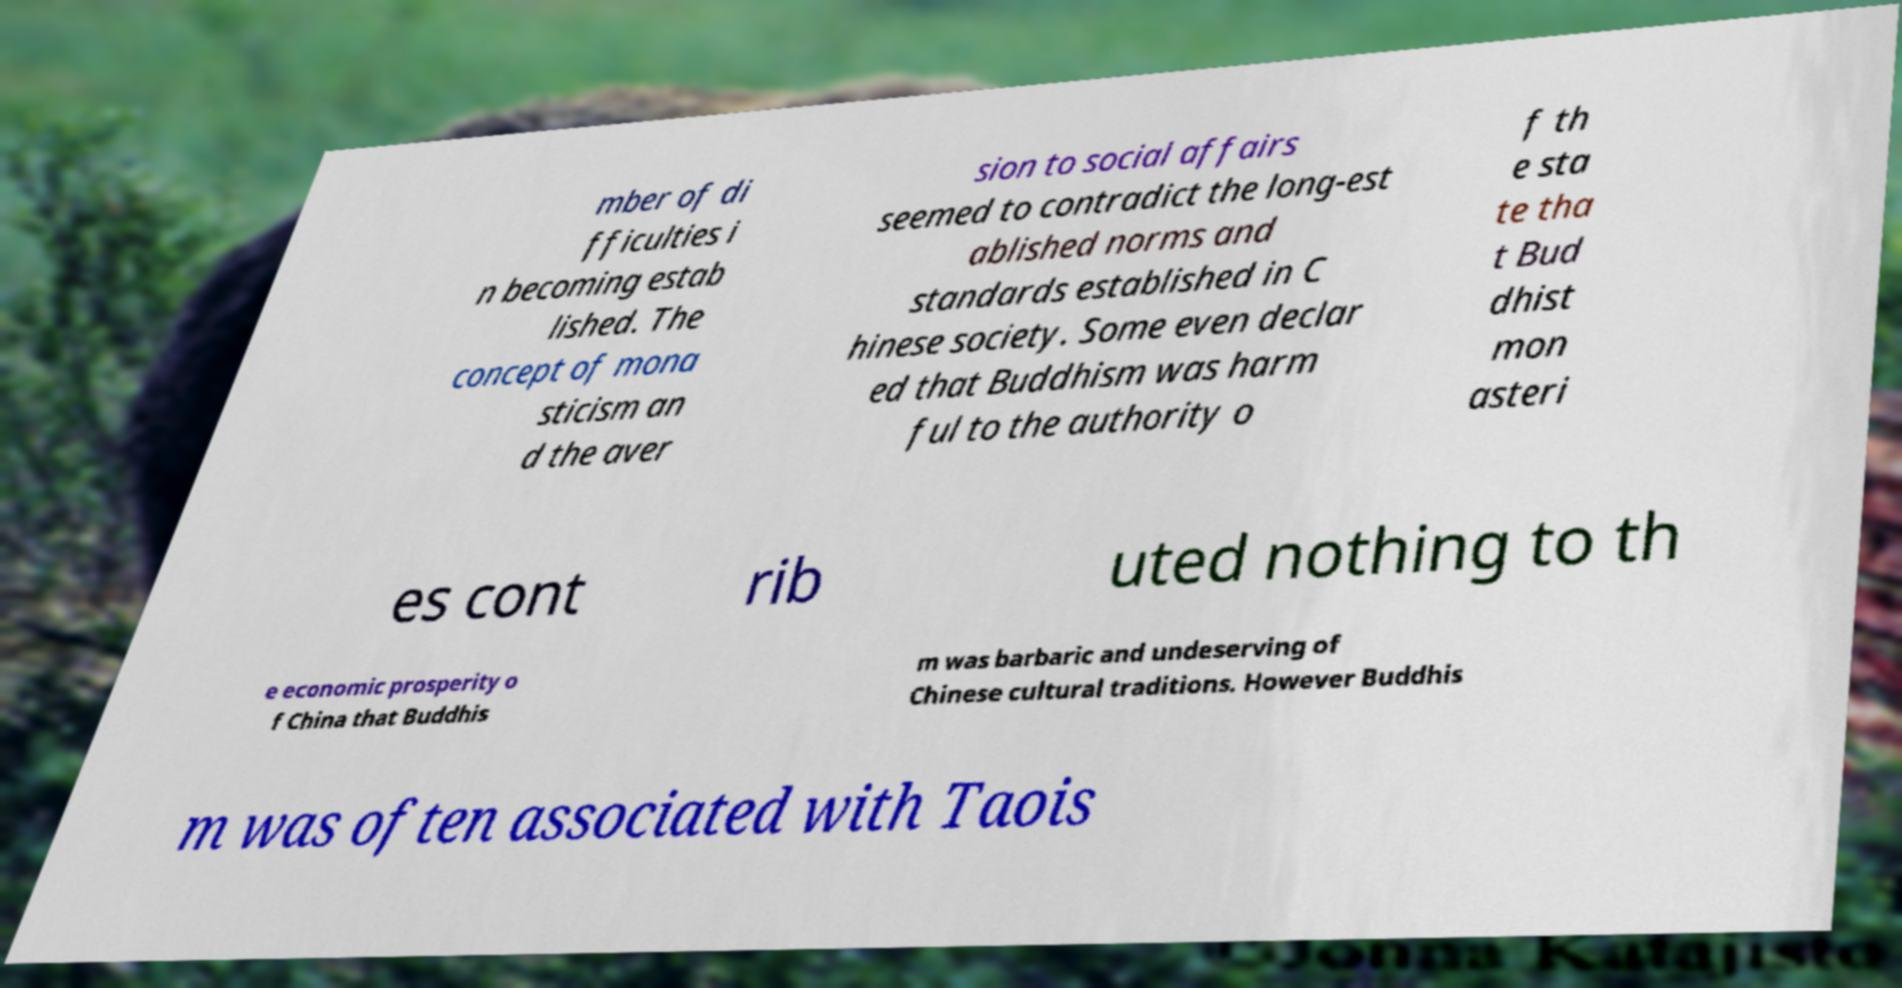I need the written content from this picture converted into text. Can you do that? mber of di fficulties i n becoming estab lished. The concept of mona sticism an d the aver sion to social affairs seemed to contradict the long-est ablished norms and standards established in C hinese society. Some even declar ed that Buddhism was harm ful to the authority o f th e sta te tha t Bud dhist mon asteri es cont rib uted nothing to th e economic prosperity o f China that Buddhis m was barbaric and undeserving of Chinese cultural traditions. However Buddhis m was often associated with Taois 